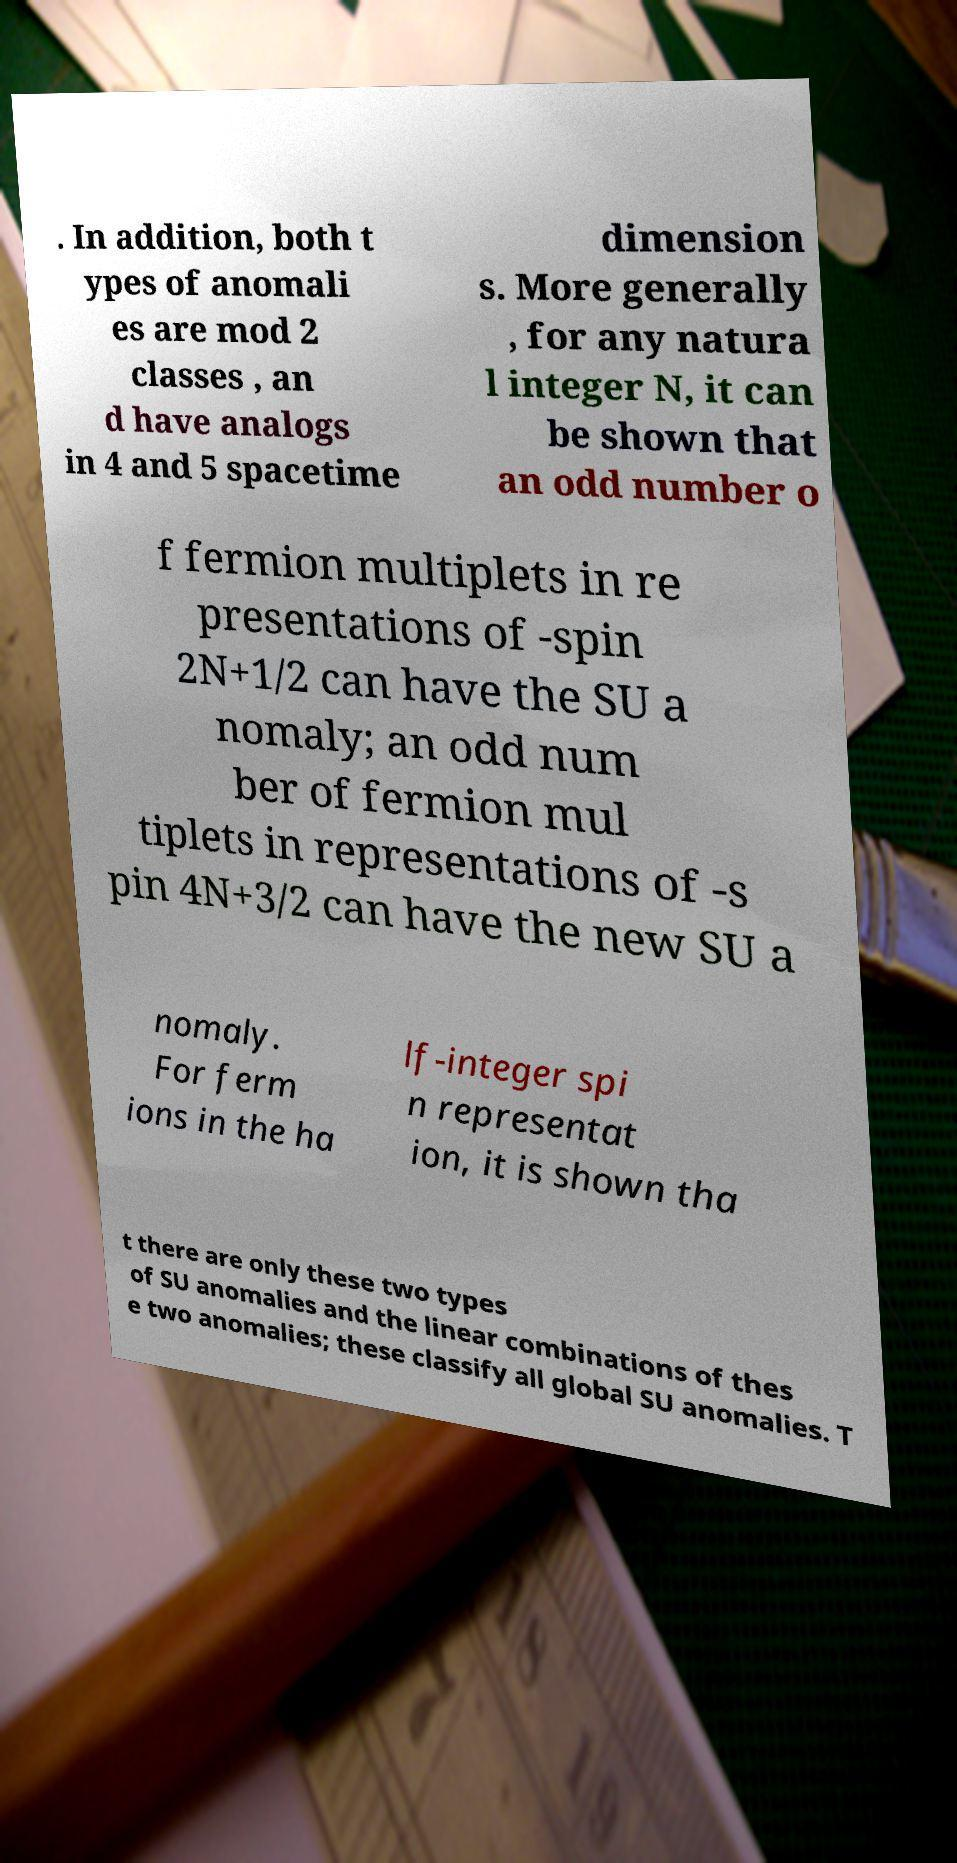There's text embedded in this image that I need extracted. Can you transcribe it verbatim? . In addition, both t ypes of anomali es are mod 2 classes , an d have analogs in 4 and 5 spacetime dimension s. More generally , for any natura l integer N, it can be shown that an odd number o f fermion multiplets in re presentations of -spin 2N+1/2 can have the SU a nomaly; an odd num ber of fermion mul tiplets in representations of -s pin 4N+3/2 can have the new SU a nomaly. For ferm ions in the ha lf-integer spi n representat ion, it is shown tha t there are only these two types of SU anomalies and the linear combinations of thes e two anomalies; these classify all global SU anomalies. T 